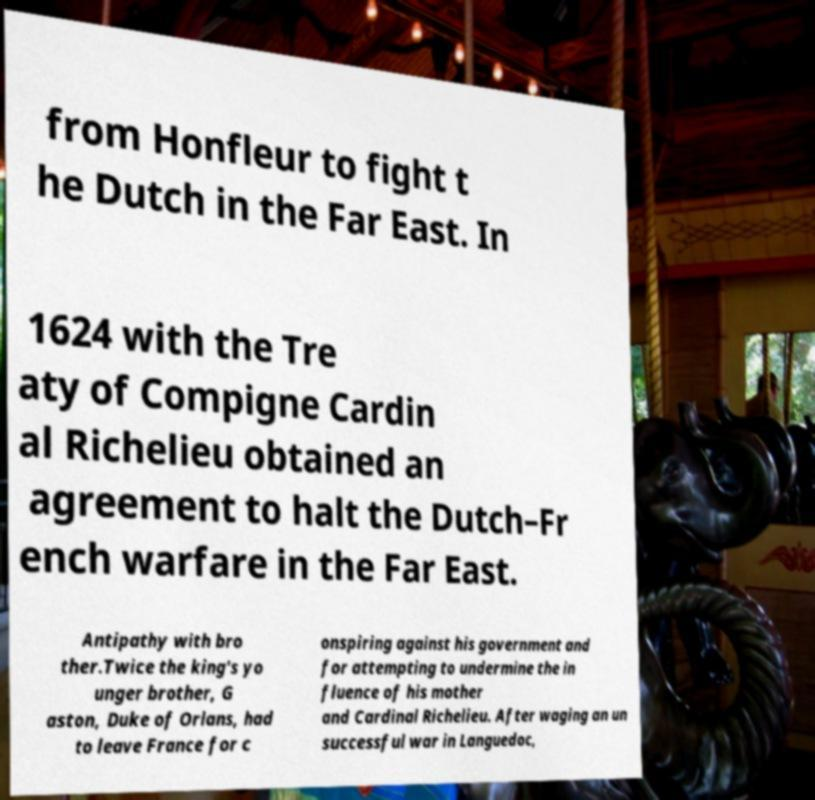Please identify and transcribe the text found in this image. from Honfleur to fight t he Dutch in the Far East. In 1624 with the Tre aty of Compigne Cardin al Richelieu obtained an agreement to halt the Dutch–Fr ench warfare in the Far East. Antipathy with bro ther.Twice the king's yo unger brother, G aston, Duke of Orlans, had to leave France for c onspiring against his government and for attempting to undermine the in fluence of his mother and Cardinal Richelieu. After waging an un successful war in Languedoc, 